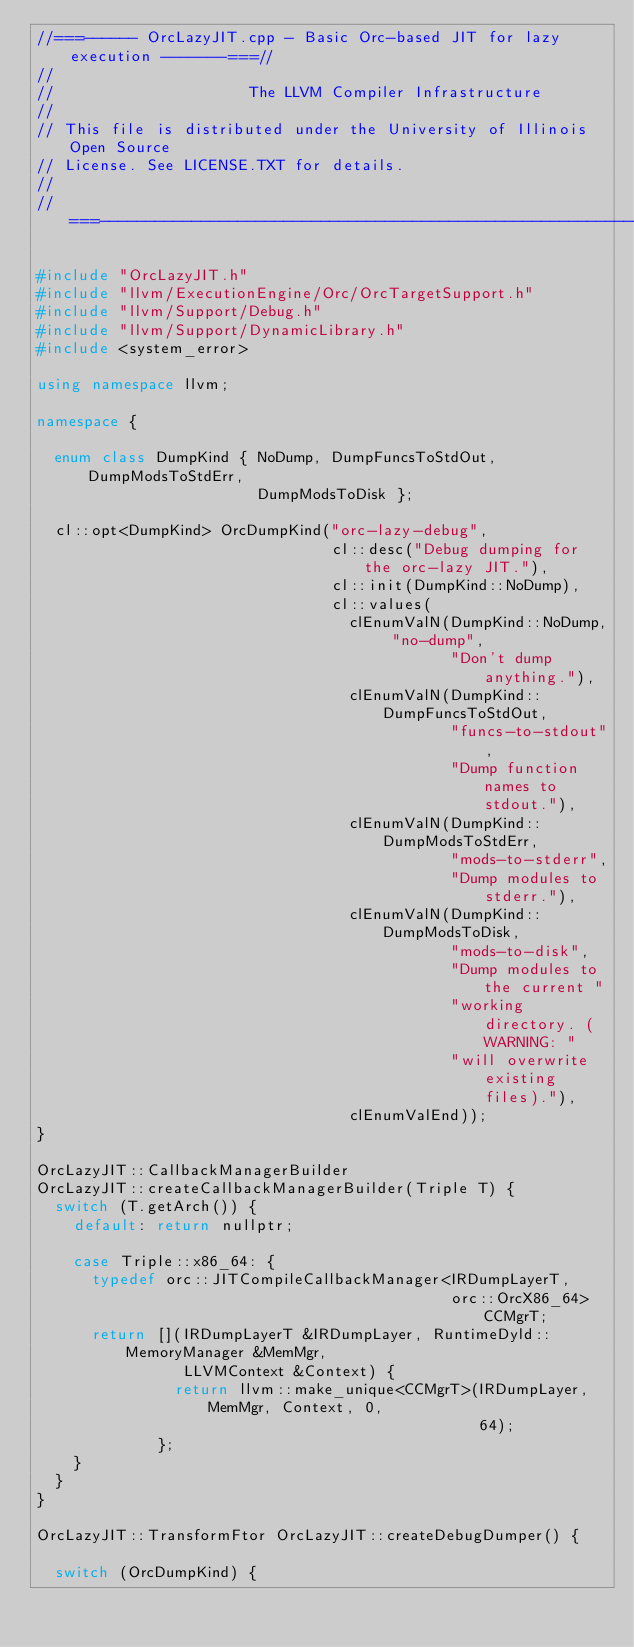<code> <loc_0><loc_0><loc_500><loc_500><_C++_>//===------ OrcLazyJIT.cpp - Basic Orc-based JIT for lazy execution -------===//
//
//                     The LLVM Compiler Infrastructure
//
// This file is distributed under the University of Illinois Open Source
// License. See LICENSE.TXT for details.
//
//===----------------------------------------------------------------------===//

#include "OrcLazyJIT.h"
#include "llvm/ExecutionEngine/Orc/OrcTargetSupport.h"
#include "llvm/Support/Debug.h"
#include "llvm/Support/DynamicLibrary.h"
#include <system_error>

using namespace llvm;

namespace {

  enum class DumpKind { NoDump, DumpFuncsToStdOut, DumpModsToStdErr,
                        DumpModsToDisk };

  cl::opt<DumpKind> OrcDumpKind("orc-lazy-debug",
                                cl::desc("Debug dumping for the orc-lazy JIT."),
                                cl::init(DumpKind::NoDump),
                                cl::values(
                                  clEnumValN(DumpKind::NoDump, "no-dump",
                                             "Don't dump anything."),
                                  clEnumValN(DumpKind::DumpFuncsToStdOut,
                                             "funcs-to-stdout",
                                             "Dump function names to stdout."),
                                  clEnumValN(DumpKind::DumpModsToStdErr,
                                             "mods-to-stderr",
                                             "Dump modules to stderr."),
                                  clEnumValN(DumpKind::DumpModsToDisk,
                                             "mods-to-disk",
                                             "Dump modules to the current "
                                             "working directory. (WARNING: "
                                             "will overwrite existing files)."),
                                  clEnumValEnd));
}

OrcLazyJIT::CallbackManagerBuilder
OrcLazyJIT::createCallbackManagerBuilder(Triple T) {
  switch (T.getArch()) {
    default: return nullptr;

    case Triple::x86_64: {
      typedef orc::JITCompileCallbackManager<IRDumpLayerT,
                                             orc::OrcX86_64> CCMgrT;
      return [](IRDumpLayerT &IRDumpLayer, RuntimeDyld::MemoryManager &MemMgr,
                LLVMContext &Context) {
               return llvm::make_unique<CCMgrT>(IRDumpLayer, MemMgr, Context, 0,
                                                64);
             };
    }
  }
}

OrcLazyJIT::TransformFtor OrcLazyJIT::createDebugDumper() {

  switch (OrcDumpKind) {</code> 